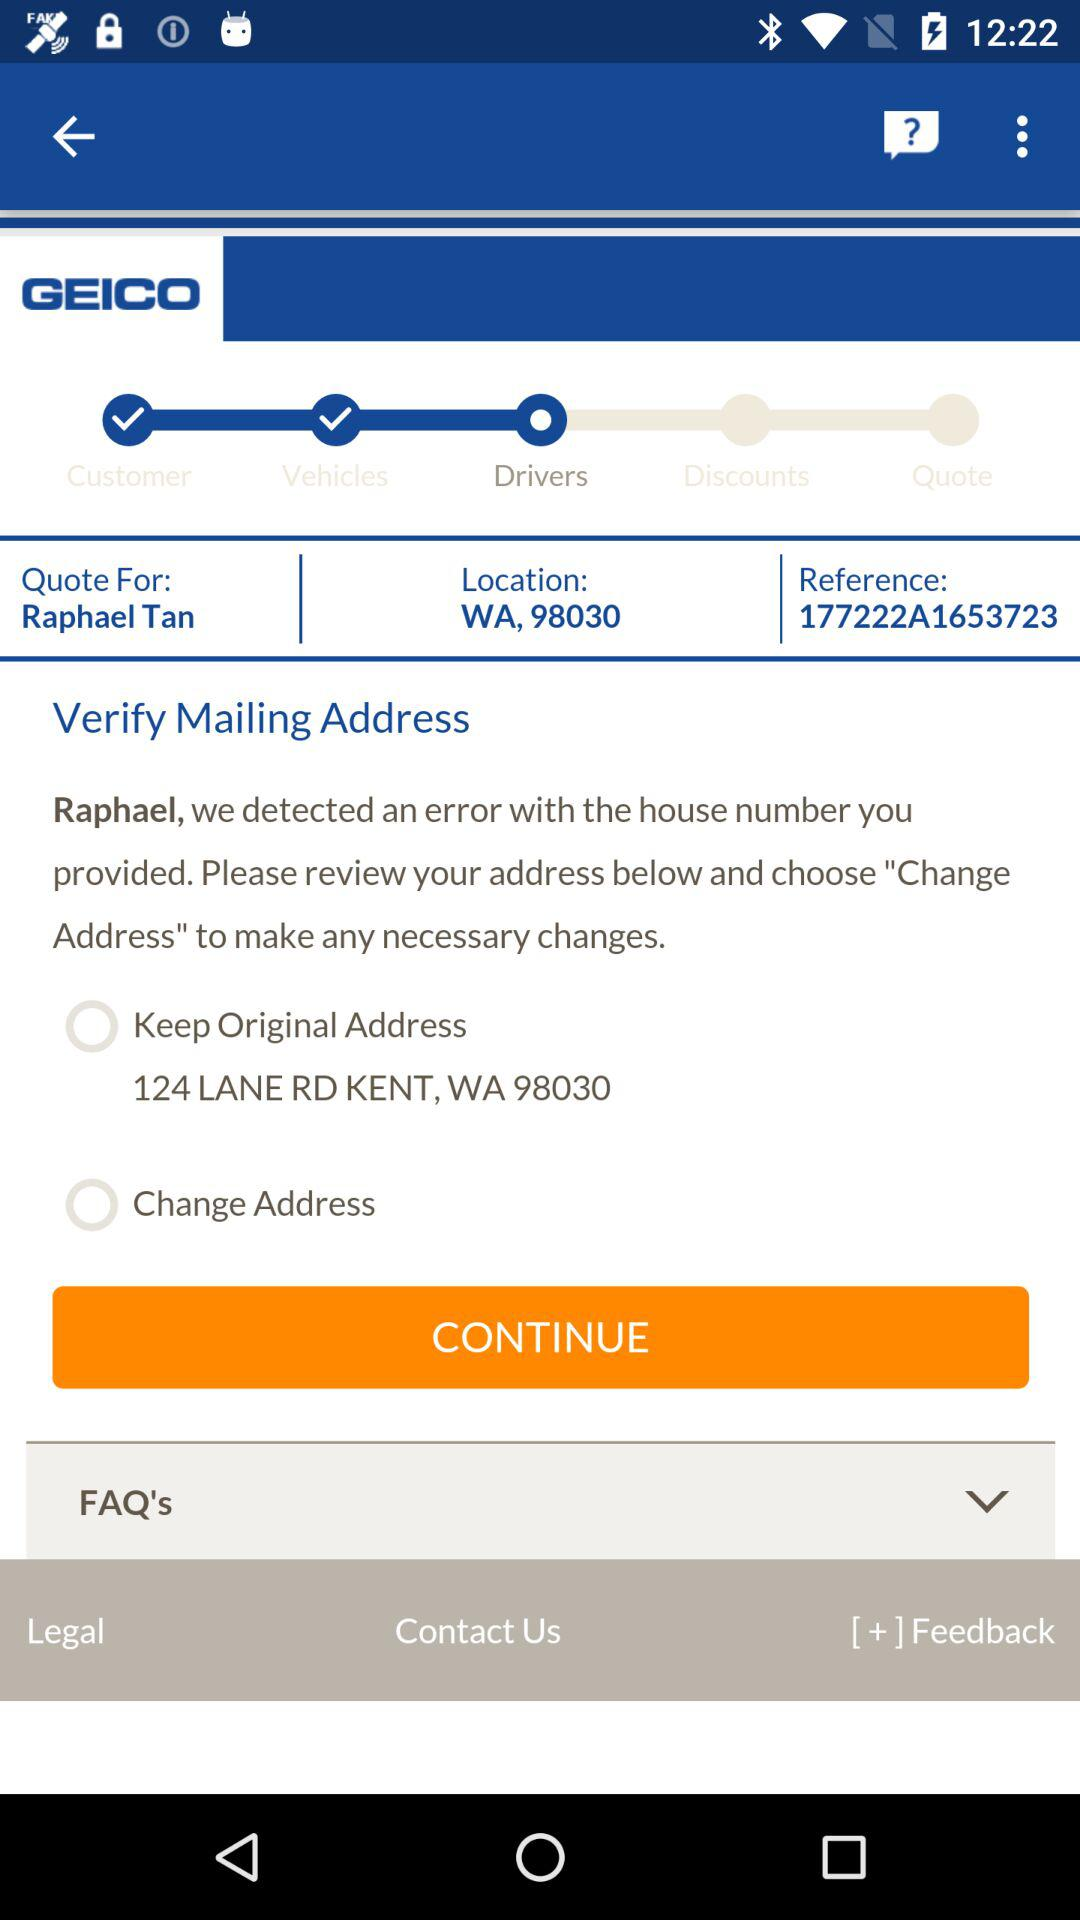What is the reference number? The reference number is 177222A1653723. 